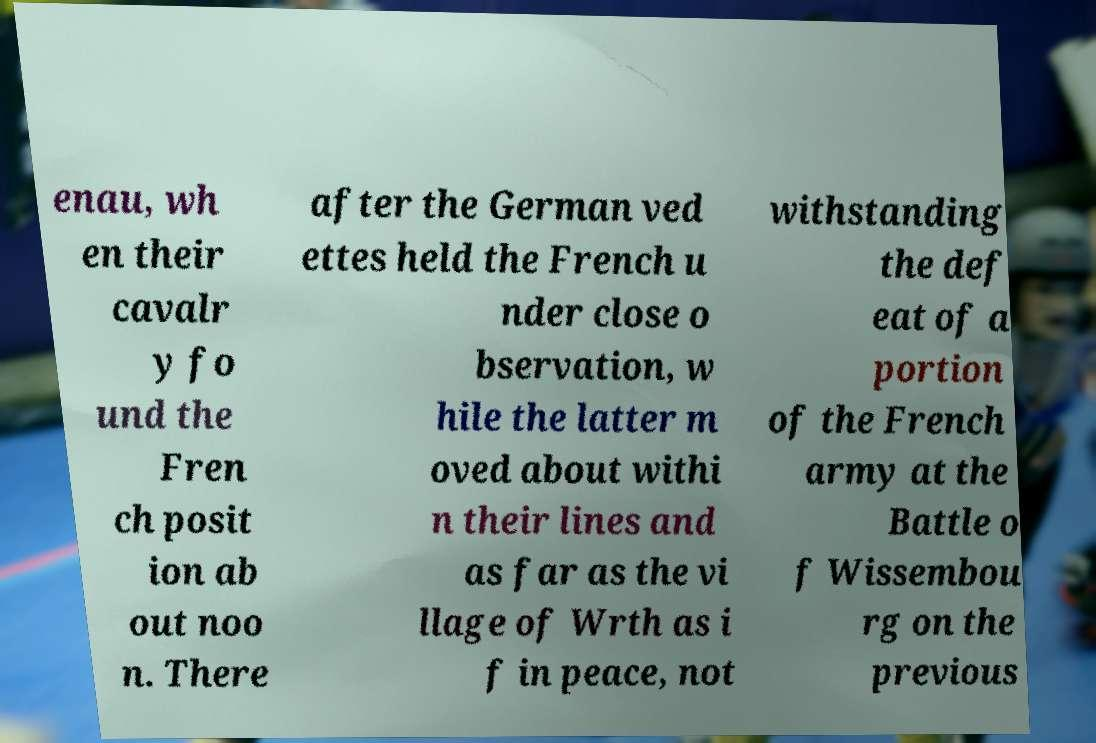I need the written content from this picture converted into text. Can you do that? enau, wh en their cavalr y fo und the Fren ch posit ion ab out noo n. There after the German ved ettes held the French u nder close o bservation, w hile the latter m oved about withi n their lines and as far as the vi llage of Wrth as i f in peace, not withstanding the def eat of a portion of the French army at the Battle o f Wissembou rg on the previous 